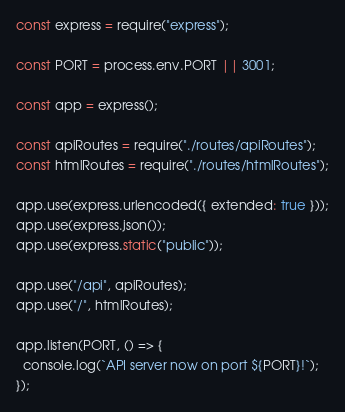<code> <loc_0><loc_0><loc_500><loc_500><_JavaScript_>const express = require("express");

const PORT = process.env.PORT || 3001;

const app = express();

const apiRoutes = require("./routes/apiRoutes");
const htmlRoutes = require("./routes/htmlRoutes");

app.use(express.urlencoded({ extended: true }));
app.use(express.json());
app.use(express.static("public"));

app.use("/api", apiRoutes);
app.use("/", htmlRoutes);

app.listen(PORT, () => {
  console.log(`API server now on port ${PORT}!`);
});
</code> 